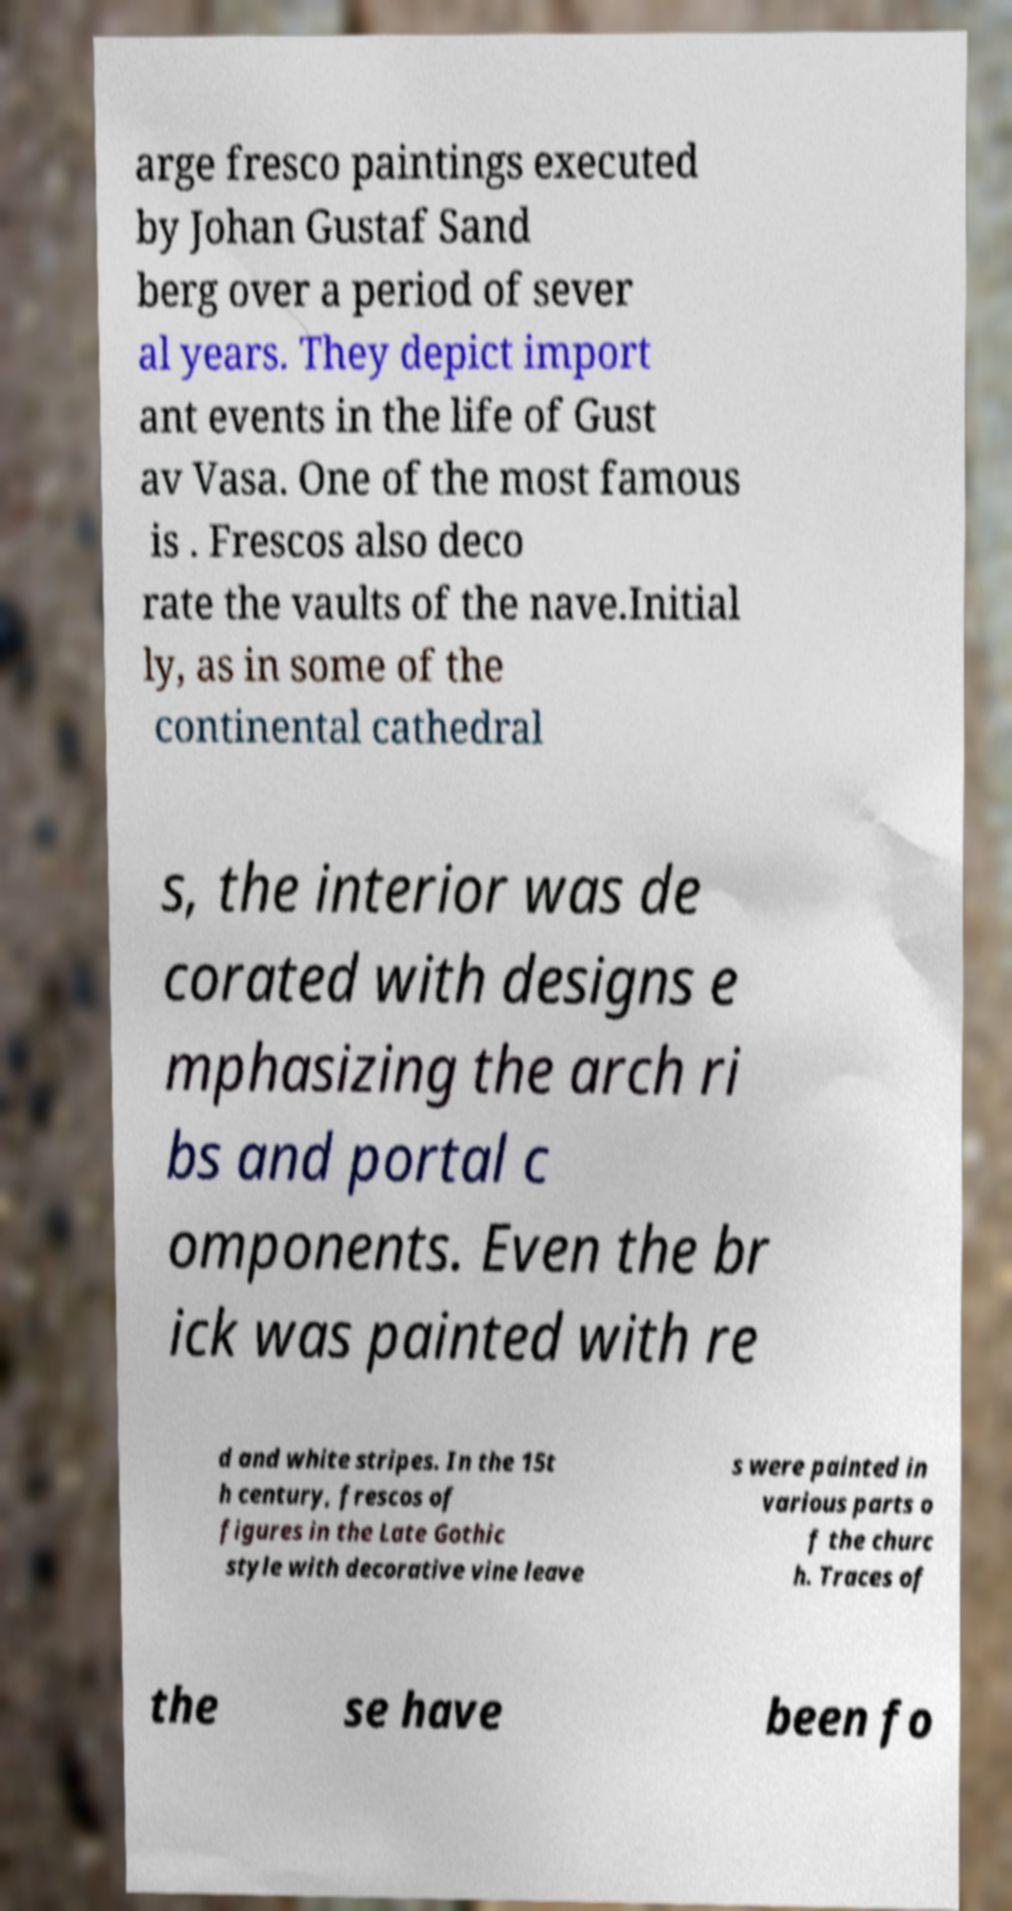What messages or text are displayed in this image? I need them in a readable, typed format. arge fresco paintings executed by Johan Gustaf Sand berg over a period of sever al years. They depict import ant events in the life of Gust av Vasa. One of the most famous is . Frescos also deco rate the vaults of the nave.Initial ly, as in some of the continental cathedral s, the interior was de corated with designs e mphasizing the arch ri bs and portal c omponents. Even the br ick was painted with re d and white stripes. In the 15t h century, frescos of figures in the Late Gothic style with decorative vine leave s were painted in various parts o f the churc h. Traces of the se have been fo 